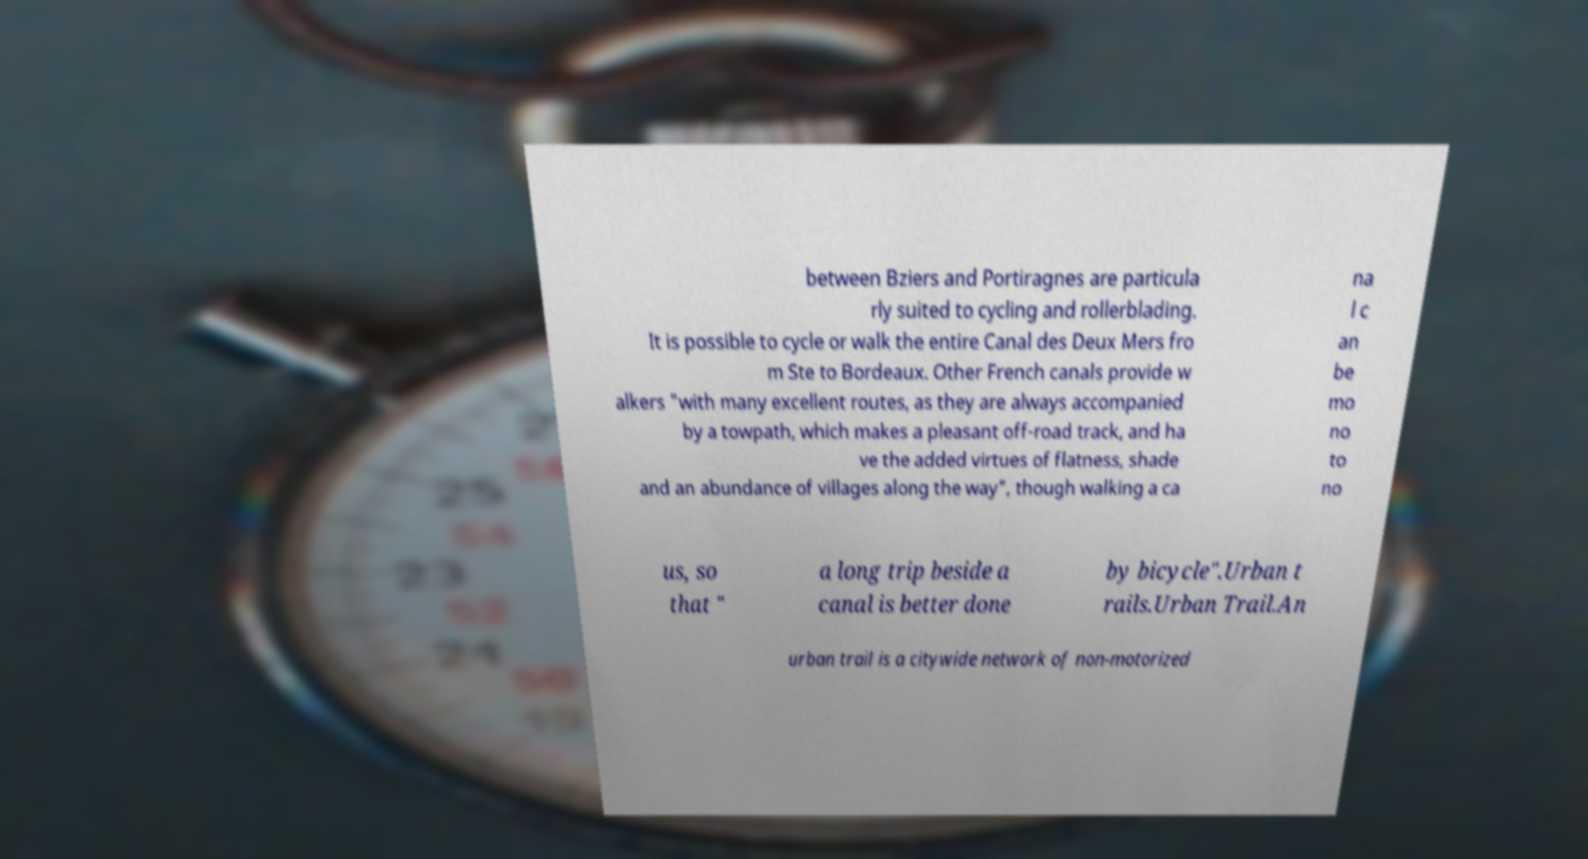Could you assist in decoding the text presented in this image and type it out clearly? between Bziers and Portiragnes are particula rly suited to cycling and rollerblading. It is possible to cycle or walk the entire Canal des Deux Mers fro m Ste to Bordeaux. Other French canals provide w alkers "with many excellent routes, as they are always accompanied by a towpath, which makes a pleasant off-road track, and ha ve the added virtues of flatness, shade and an abundance of villages along the way", though walking a ca na l c an be mo no to no us, so that " a long trip beside a canal is better done by bicycle".Urban t rails.Urban Trail.An urban trail is a citywide network of non-motorized 